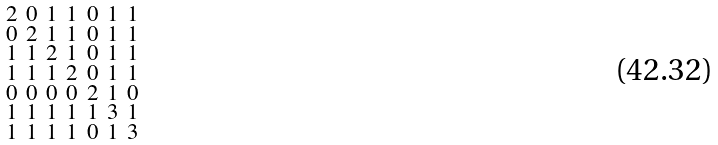<formula> <loc_0><loc_0><loc_500><loc_500>\begin{smallmatrix} 2 & 0 & 1 & 1 & 0 & 1 & 1 \\ 0 & 2 & 1 & 1 & 0 & 1 & 1 \\ 1 & 1 & 2 & 1 & 0 & 1 & 1 \\ 1 & 1 & 1 & 2 & 0 & 1 & 1 \\ 0 & 0 & 0 & 0 & 2 & 1 & 0 \\ 1 & 1 & 1 & 1 & 1 & 3 & 1 \\ 1 & 1 & 1 & 1 & 0 & 1 & 3 \end{smallmatrix}</formula> 